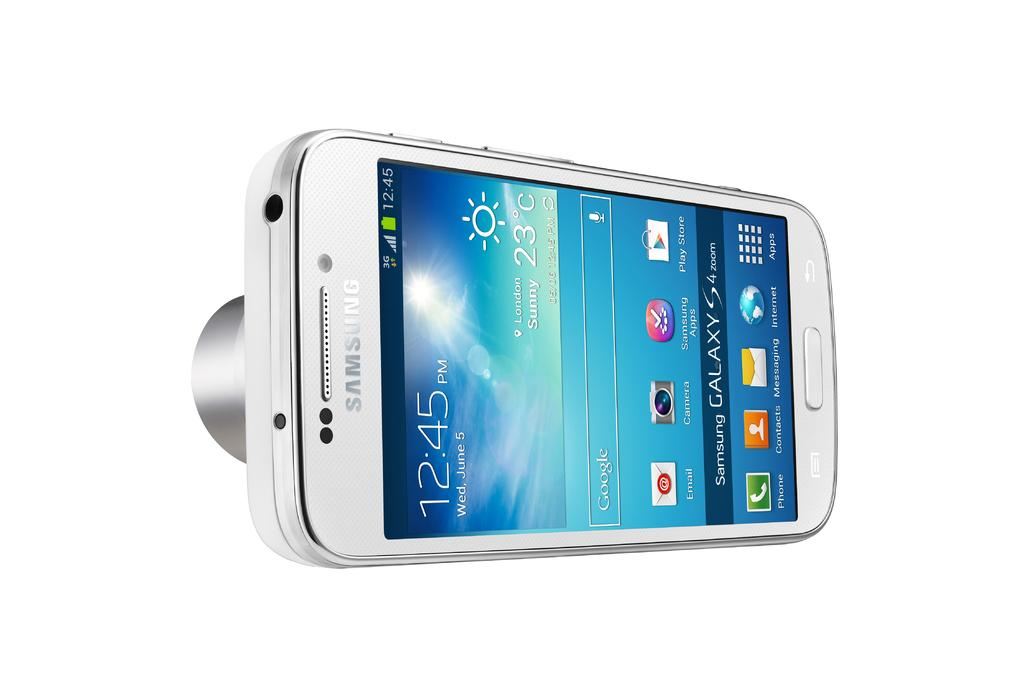Provide a one-sentence caption for the provided image. A Samsung Galaxy S 4 that is turned on and has the time 12:45 on it. 